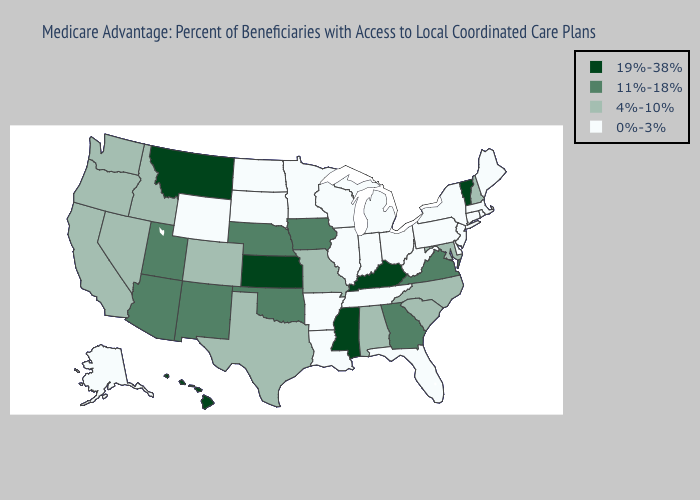Does the first symbol in the legend represent the smallest category?
Write a very short answer. No. What is the highest value in the Northeast ?
Quick response, please. 19%-38%. Which states have the lowest value in the Northeast?
Short answer required. Connecticut, Massachusetts, Maine, New Jersey, New York, Pennsylvania, Rhode Island. Name the states that have a value in the range 4%-10%?
Answer briefly. California, Colorado, Idaho, Maryland, Missouri, North Carolina, New Hampshire, Nevada, Oregon, South Carolina, Texas, Washington, Alabama. What is the highest value in the Northeast ?
Answer briefly. 19%-38%. Does Nebraska have a lower value than Vermont?
Concise answer only. Yes. Does Kansas have the highest value in the USA?
Be succinct. Yes. What is the highest value in states that border Montana?
Write a very short answer. 4%-10%. What is the value of Kansas?
Quick response, please. 19%-38%. Is the legend a continuous bar?
Keep it brief. No. What is the highest value in the USA?
Write a very short answer. 19%-38%. Name the states that have a value in the range 11%-18%?
Quick response, please. Georgia, Iowa, Nebraska, New Mexico, Oklahoma, Utah, Virginia, Arizona. Which states hav the highest value in the South?
Short answer required. Kentucky, Mississippi. Among the states that border South Dakota , which have the highest value?
Write a very short answer. Montana. Name the states that have a value in the range 11%-18%?
Be succinct. Georgia, Iowa, Nebraska, New Mexico, Oklahoma, Utah, Virginia, Arizona. 